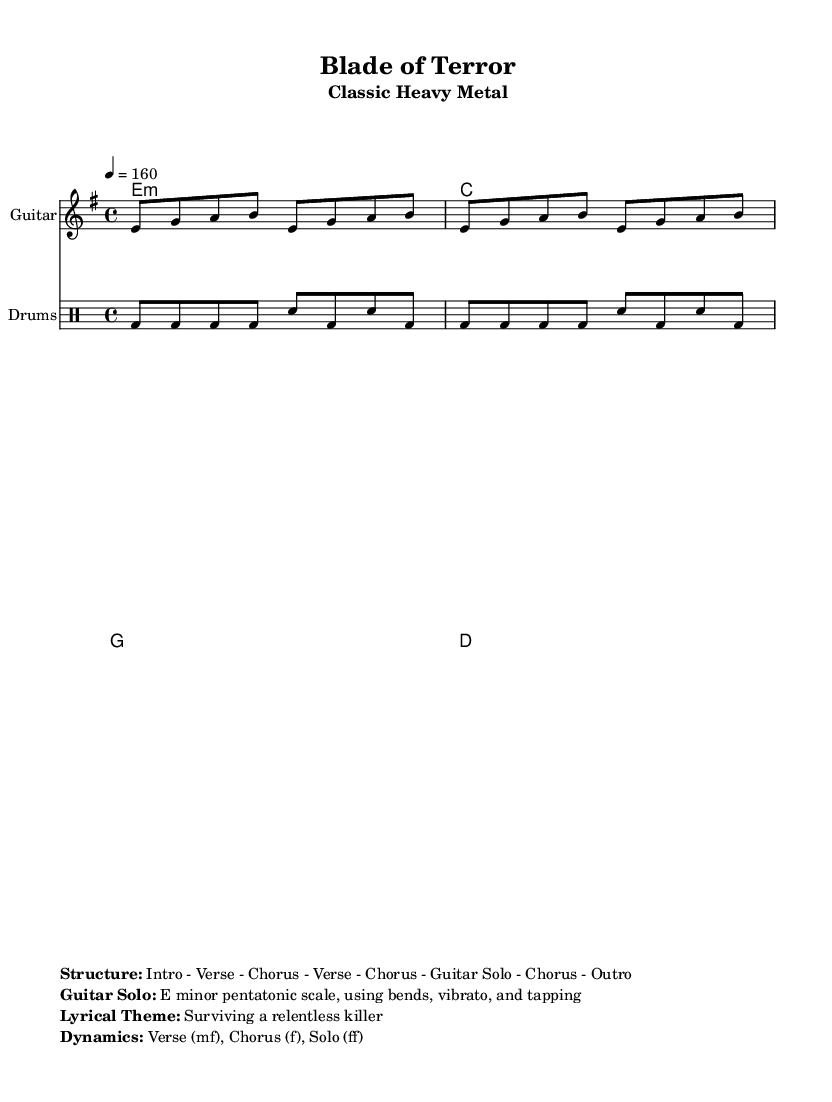What is the key signature of this music? The key signature is indicated at the beginning of the score, showing E minor, which has one sharp (F#).
Answer: E minor What is the time signature of this music? The time signature is found at the start of the piece, presented as 4/4, indicating four beats per measure.
Answer: 4/4 What is the tempo marking for this music? The tempo marking is noted in beats per minute (BPM) at the start, set to 160, which indicates a fast pace.
Answer: 160 How many sections are in the song structure? The structure lists the number of distinct parts: Intro, Verse, Chorus, Verse, Chorus, Guitar Solo, Chorus, and Outro, totaling seven sections.
Answer: 7 What is the dynamic for the Chorus? Dynamics are noted in the markup section, where "Chorus" is marked with "f," indicating it should be played loud.
Answer: f What type of scale is used in the guitar solo? The markup specifies the scale used for the guitar solo, which is the E minor pentatonic scale, a common choice in heavy metal.
Answer: E minor pentatonic scale What lyrical theme is portrayed in this music? The lyrical theme is mentioned in the markup section as "Surviving a relentless killer," indicating a horror-related narrative typical in slasher films.
Answer: Surviving a relentless killer 